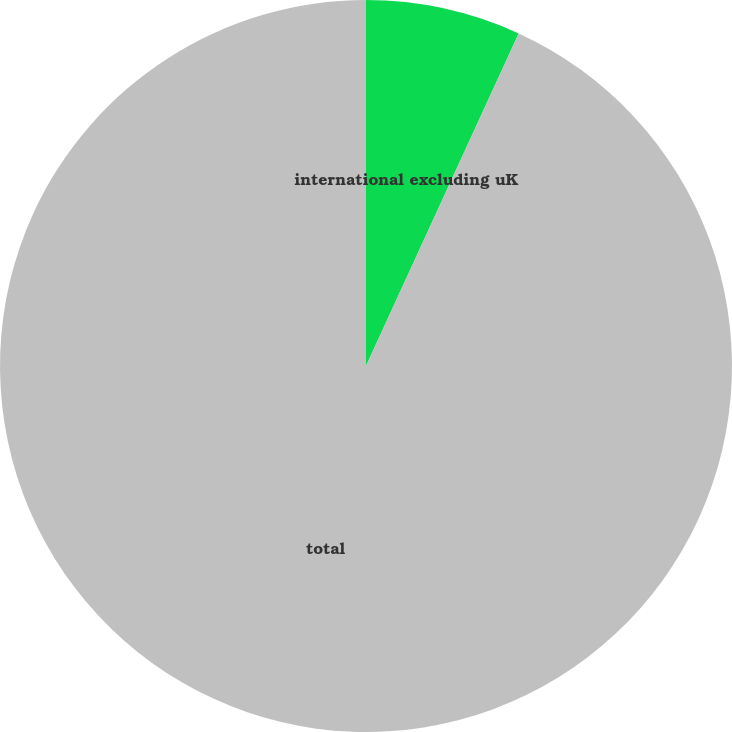Convert chart. <chart><loc_0><loc_0><loc_500><loc_500><pie_chart><fcel>international excluding uK<fcel>total<nl><fcel>6.85%<fcel>93.15%<nl></chart> 